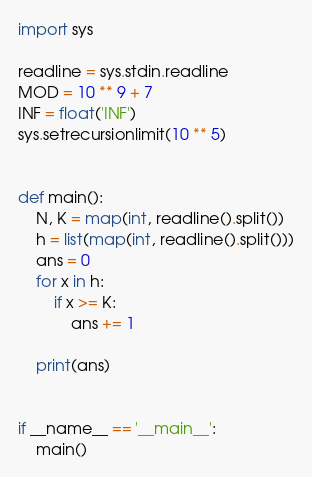<code> <loc_0><loc_0><loc_500><loc_500><_Python_>import sys

readline = sys.stdin.readline
MOD = 10 ** 9 + 7
INF = float('INF')
sys.setrecursionlimit(10 ** 5)


def main():
    N, K = map(int, readline().split())
    h = list(map(int, readline().split()))
    ans = 0
    for x in h:
        if x >= K:
            ans += 1

    print(ans)


if __name__ == '__main__':
    main()
</code> 